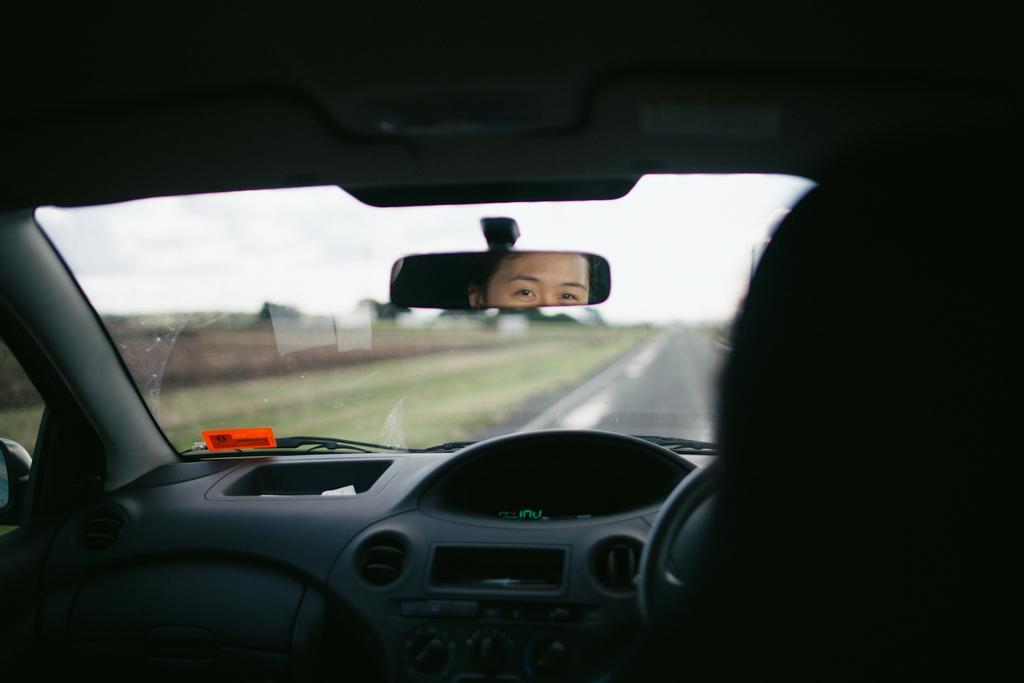Can you describe this image briefly? This is an inside view of a car. We can see a person in the mirror. There is a road. 